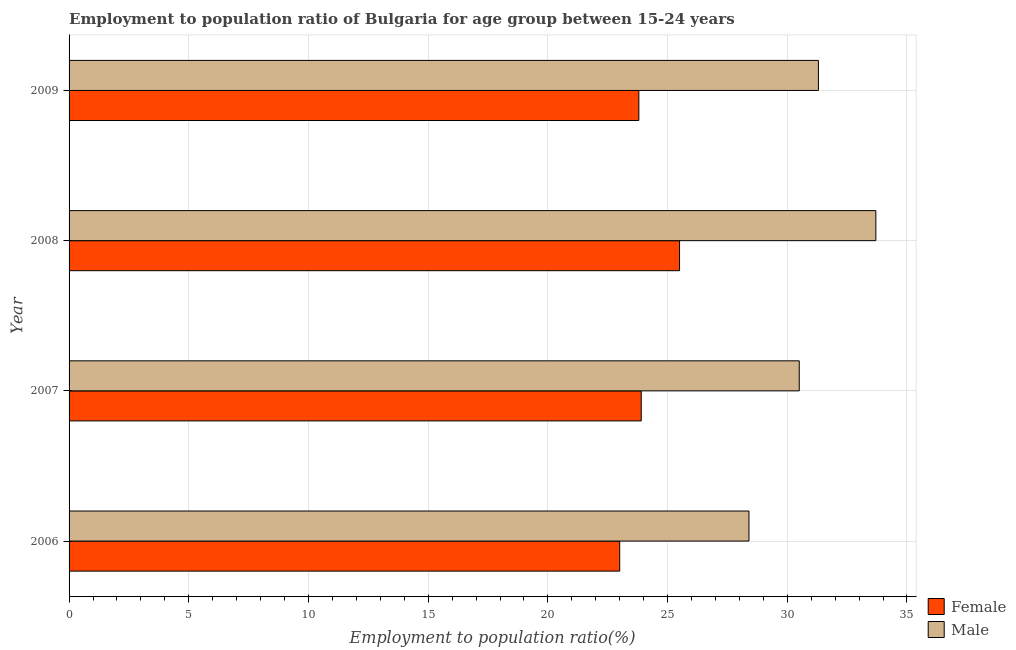How many groups of bars are there?
Give a very brief answer. 4. How many bars are there on the 3rd tick from the top?
Offer a very short reply. 2. How many bars are there on the 2nd tick from the bottom?
Ensure brevity in your answer.  2. What is the label of the 4th group of bars from the top?
Ensure brevity in your answer.  2006. What is the employment to population ratio(male) in 2008?
Your response must be concise. 33.7. Across all years, what is the minimum employment to population ratio(female)?
Offer a terse response. 23. What is the total employment to population ratio(male) in the graph?
Make the answer very short. 123.9. What is the difference between the employment to population ratio(female) in 2006 and that in 2008?
Your response must be concise. -2.5. What is the difference between the employment to population ratio(female) in 2009 and the employment to population ratio(male) in 2006?
Ensure brevity in your answer.  -4.6. What is the average employment to population ratio(female) per year?
Provide a succinct answer. 24.05. In how many years, is the employment to population ratio(female) greater than 13 %?
Provide a short and direct response. 4. What is the ratio of the employment to population ratio(female) in 2007 to that in 2008?
Make the answer very short. 0.94. Is the employment to population ratio(male) in 2006 less than that in 2009?
Offer a very short reply. Yes. Is the difference between the employment to population ratio(female) in 2006 and 2008 greater than the difference between the employment to population ratio(male) in 2006 and 2008?
Offer a very short reply. Yes. What is the difference between the highest and the second highest employment to population ratio(male)?
Your response must be concise. 2.4. What is the difference between the highest and the lowest employment to population ratio(female)?
Your answer should be compact. 2.5. Is the sum of the employment to population ratio(male) in 2006 and 2007 greater than the maximum employment to population ratio(female) across all years?
Ensure brevity in your answer.  Yes. What does the 1st bar from the top in 2008 represents?
Your response must be concise. Male. How many bars are there?
Give a very brief answer. 8. Are all the bars in the graph horizontal?
Ensure brevity in your answer.  Yes. How many years are there in the graph?
Your response must be concise. 4. What is the difference between two consecutive major ticks on the X-axis?
Your response must be concise. 5. Are the values on the major ticks of X-axis written in scientific E-notation?
Keep it short and to the point. No. Does the graph contain any zero values?
Give a very brief answer. No. Does the graph contain grids?
Your response must be concise. Yes. Where does the legend appear in the graph?
Offer a very short reply. Bottom right. What is the title of the graph?
Make the answer very short. Employment to population ratio of Bulgaria for age group between 15-24 years. What is the label or title of the X-axis?
Ensure brevity in your answer.  Employment to population ratio(%). What is the Employment to population ratio(%) of Male in 2006?
Provide a succinct answer. 28.4. What is the Employment to population ratio(%) of Female in 2007?
Ensure brevity in your answer.  23.9. What is the Employment to population ratio(%) in Male in 2007?
Ensure brevity in your answer.  30.5. What is the Employment to population ratio(%) of Female in 2008?
Make the answer very short. 25.5. What is the Employment to population ratio(%) in Male in 2008?
Ensure brevity in your answer.  33.7. What is the Employment to population ratio(%) of Female in 2009?
Provide a short and direct response. 23.8. What is the Employment to population ratio(%) of Male in 2009?
Offer a terse response. 31.3. Across all years, what is the maximum Employment to population ratio(%) in Male?
Your answer should be compact. 33.7. Across all years, what is the minimum Employment to population ratio(%) in Female?
Your answer should be very brief. 23. Across all years, what is the minimum Employment to population ratio(%) of Male?
Give a very brief answer. 28.4. What is the total Employment to population ratio(%) in Female in the graph?
Make the answer very short. 96.2. What is the total Employment to population ratio(%) in Male in the graph?
Your answer should be compact. 123.9. What is the difference between the Employment to population ratio(%) in Male in 2006 and that in 2007?
Offer a very short reply. -2.1. What is the difference between the Employment to population ratio(%) in Male in 2006 and that in 2008?
Offer a terse response. -5.3. What is the difference between the Employment to population ratio(%) of Female in 2007 and that in 2008?
Make the answer very short. -1.6. What is the difference between the Employment to population ratio(%) of Female in 2007 and that in 2009?
Make the answer very short. 0.1. What is the difference between the Employment to population ratio(%) in Male in 2007 and that in 2009?
Your answer should be very brief. -0.8. What is the difference between the Employment to population ratio(%) of Female in 2008 and that in 2009?
Give a very brief answer. 1.7. What is the difference between the Employment to population ratio(%) of Male in 2008 and that in 2009?
Your answer should be compact. 2.4. What is the difference between the Employment to population ratio(%) of Female in 2006 and the Employment to population ratio(%) of Male in 2007?
Keep it short and to the point. -7.5. What is the difference between the Employment to population ratio(%) of Female in 2006 and the Employment to population ratio(%) of Male in 2008?
Your answer should be very brief. -10.7. What is the difference between the Employment to population ratio(%) in Female in 2006 and the Employment to population ratio(%) in Male in 2009?
Your answer should be compact. -8.3. What is the difference between the Employment to population ratio(%) of Female in 2007 and the Employment to population ratio(%) of Male in 2008?
Keep it short and to the point. -9.8. What is the difference between the Employment to population ratio(%) of Female in 2007 and the Employment to population ratio(%) of Male in 2009?
Your answer should be very brief. -7.4. What is the difference between the Employment to population ratio(%) of Female in 2008 and the Employment to population ratio(%) of Male in 2009?
Ensure brevity in your answer.  -5.8. What is the average Employment to population ratio(%) of Female per year?
Provide a succinct answer. 24.05. What is the average Employment to population ratio(%) in Male per year?
Your answer should be compact. 30.98. In the year 2007, what is the difference between the Employment to population ratio(%) in Female and Employment to population ratio(%) in Male?
Provide a short and direct response. -6.6. In the year 2009, what is the difference between the Employment to population ratio(%) of Female and Employment to population ratio(%) of Male?
Offer a very short reply. -7.5. What is the ratio of the Employment to population ratio(%) in Female in 2006 to that in 2007?
Provide a short and direct response. 0.96. What is the ratio of the Employment to population ratio(%) in Male in 2006 to that in 2007?
Provide a succinct answer. 0.93. What is the ratio of the Employment to population ratio(%) of Female in 2006 to that in 2008?
Your response must be concise. 0.9. What is the ratio of the Employment to population ratio(%) of Male in 2006 to that in 2008?
Keep it short and to the point. 0.84. What is the ratio of the Employment to population ratio(%) in Female in 2006 to that in 2009?
Keep it short and to the point. 0.97. What is the ratio of the Employment to population ratio(%) in Male in 2006 to that in 2009?
Your response must be concise. 0.91. What is the ratio of the Employment to population ratio(%) in Female in 2007 to that in 2008?
Make the answer very short. 0.94. What is the ratio of the Employment to population ratio(%) of Male in 2007 to that in 2008?
Your response must be concise. 0.91. What is the ratio of the Employment to population ratio(%) of Male in 2007 to that in 2009?
Offer a terse response. 0.97. What is the ratio of the Employment to population ratio(%) in Female in 2008 to that in 2009?
Provide a short and direct response. 1.07. What is the ratio of the Employment to population ratio(%) in Male in 2008 to that in 2009?
Keep it short and to the point. 1.08. What is the difference between the highest and the lowest Employment to population ratio(%) of Female?
Your answer should be compact. 2.5. 